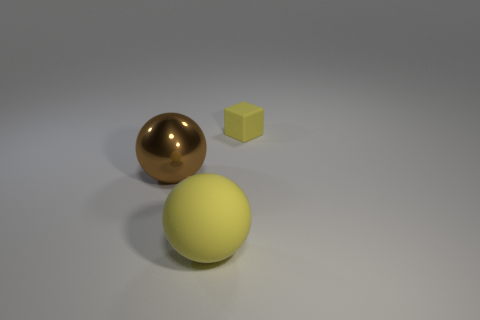Add 1 small yellow matte cubes. How many objects exist? 4 Subtract all cubes. How many objects are left? 2 Add 3 balls. How many balls are left? 5 Add 3 big blue metal cubes. How many big blue metal cubes exist? 3 Subtract 0 blue balls. How many objects are left? 3 Subtract all balls. Subtract all big red blocks. How many objects are left? 1 